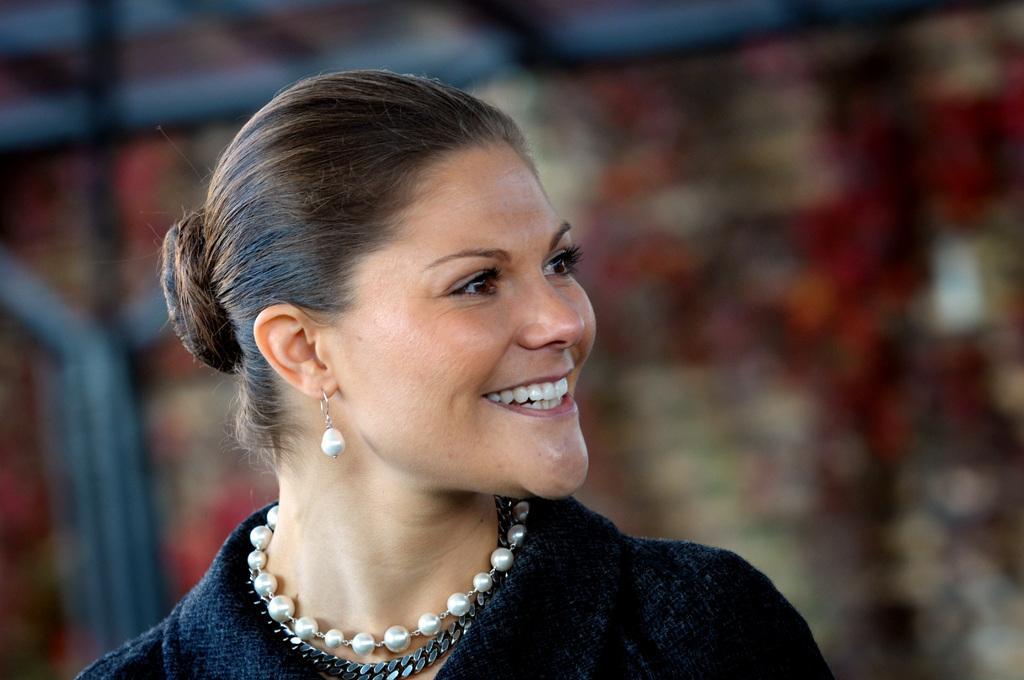Please provide a concise description of this image. In this image we can see a woman. The background of the image is blurred. 